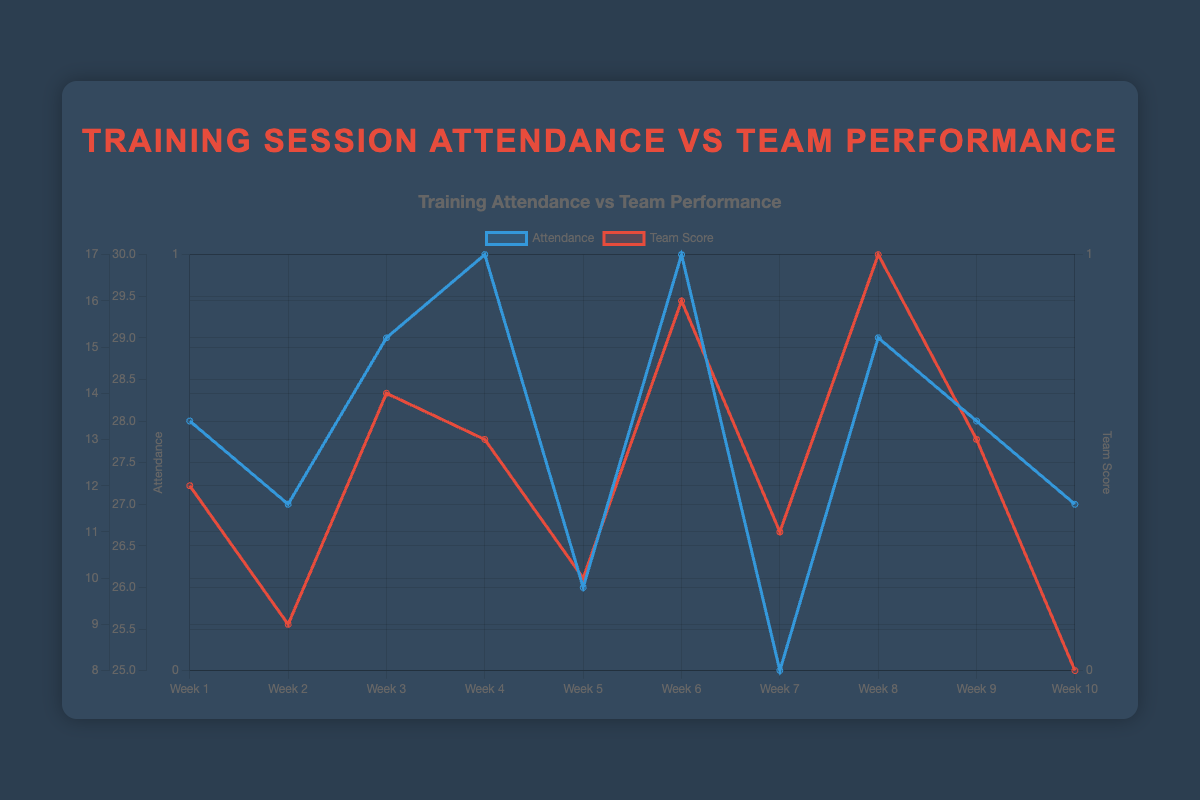How many weeks had perfect attendance (30 players)? By looking at the 'Attendance' line, identify the weeks where attendance is 30. These correspond to Weeks 4 and 6.
Answer: 2 In which week was the attendance the lowest and what was the team score that week? The lowest attendance is at Week 7, with 25 players. The team scored 11 points in Week 7.
Answer: Week 7, 11 points Did the team win more often when attendance was higher? Compare win/loss labels with attendance numbers. Wins occurred in Weeks 1, 3, 6, 8, and 9 with attendance as 28, 29, 30, 29, 28, respectively. Losses were in Weeks 2, 4, 5, 7, 10 with attendances as 27, 30, 26, 25, and 27, respectively. Win numbers are more concentrated around higher attendance.
Answer: Yes What is the average attendance over the 10 weeks? Adding up the attendance values: 28 + 27 + 29 + 30 + 26 + 30 + 25 + 29 + 28 + 27 = 279, then divide by 10.
Answer: 27.9 Which opponent did the team perform best against and what was the attendance that week? The highest team score was 17 points against Donegal in Week 8, with attendance being 29.
Answer: Donegal, 29 Was there a week where the team lost despite having perfect attendance? Check weeks where attendance was 30 and see if there was a loss. Week 4 has perfect attendance and the result is a loss to Mayo.
Answer: Yes, Week 4 Compare the team scores of Weeks 5 and 9. What is the difference and what does that imply about performance relative to attendance? Score for Week 9 is 13 and for Week 5 is 10. Difference is 13 - 10 = 3. Week 9 shows better performance and attendance was 28 compared to 26 in Week 5.
Answer: 3, better performance with higher attendance Is there a visible trend between team performance and attendance? By examining the plot, when the attendance is high, there are more frequent wins. Lower attendances such as Week 7 (25 players) tend to correspond with losses.
Answer: Higher attendance correlates with better performance What are the total goals scored by the team in the weeks they had above average attendance? Above average attendance is above 27.9 (Weeks 1, 3, 4, 6, 8, 9). Adding scores: 12 + 14 + 13 + 16 + 17 + 13 = 85 goals.
Answer: 85 goals 